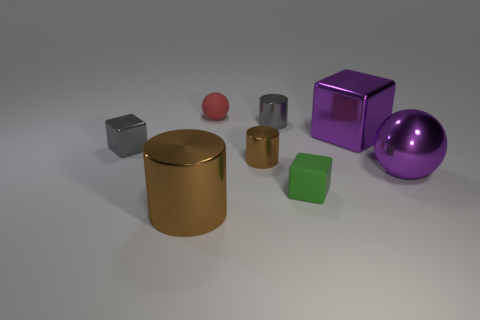Add 1 tiny purple blocks. How many objects exist? 9 Subtract all large purple metallic blocks. How many blocks are left? 2 Subtract all green balls. How many brown cylinders are left? 2 Subtract 1 cylinders. How many cylinders are left? 2 Subtract all cylinders. How many objects are left? 5 Subtract all green blocks. How many blocks are left? 2 Subtract 0 gray spheres. How many objects are left? 8 Subtract all purple cylinders. Subtract all gray balls. How many cylinders are left? 3 Subtract all purple metallic cubes. Subtract all purple metal spheres. How many objects are left? 6 Add 1 purple shiny objects. How many purple shiny objects are left? 3 